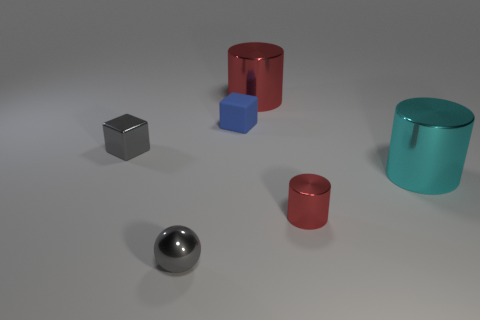How many tiny purple cylinders are there? 0 